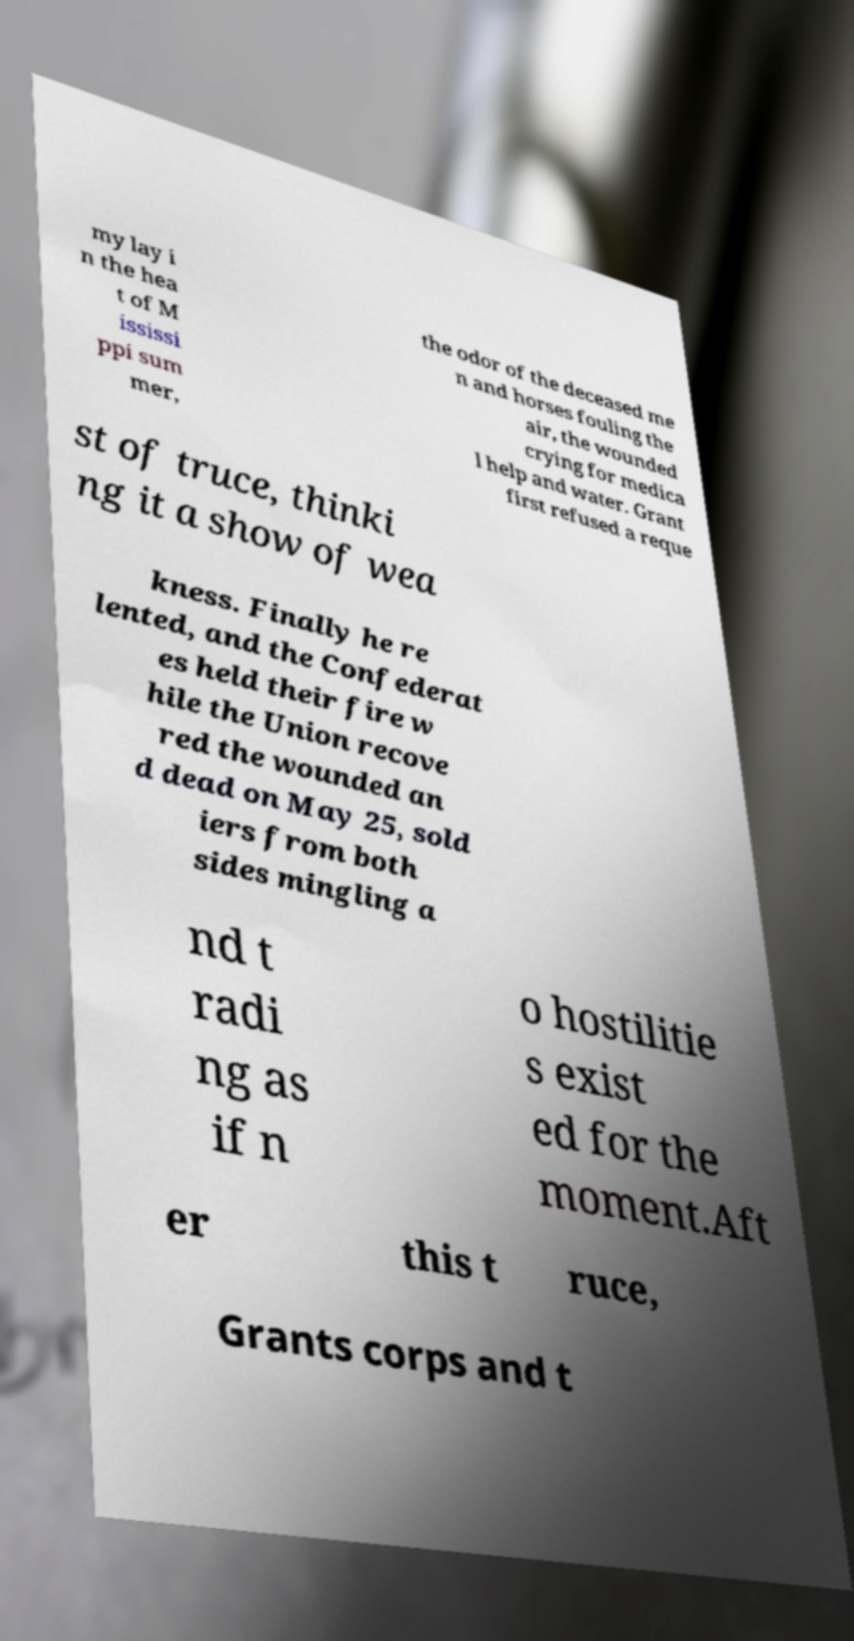Can you accurately transcribe the text from the provided image for me? my lay i n the hea t of M ississi ppi sum mer, the odor of the deceased me n and horses fouling the air, the wounded crying for medica l help and water. Grant first refused a reque st of truce, thinki ng it a show of wea kness. Finally he re lented, and the Confederat es held their fire w hile the Union recove red the wounded an d dead on May 25, sold iers from both sides mingling a nd t radi ng as if n o hostilitie s exist ed for the moment.Aft er this t ruce, Grants corps and t 